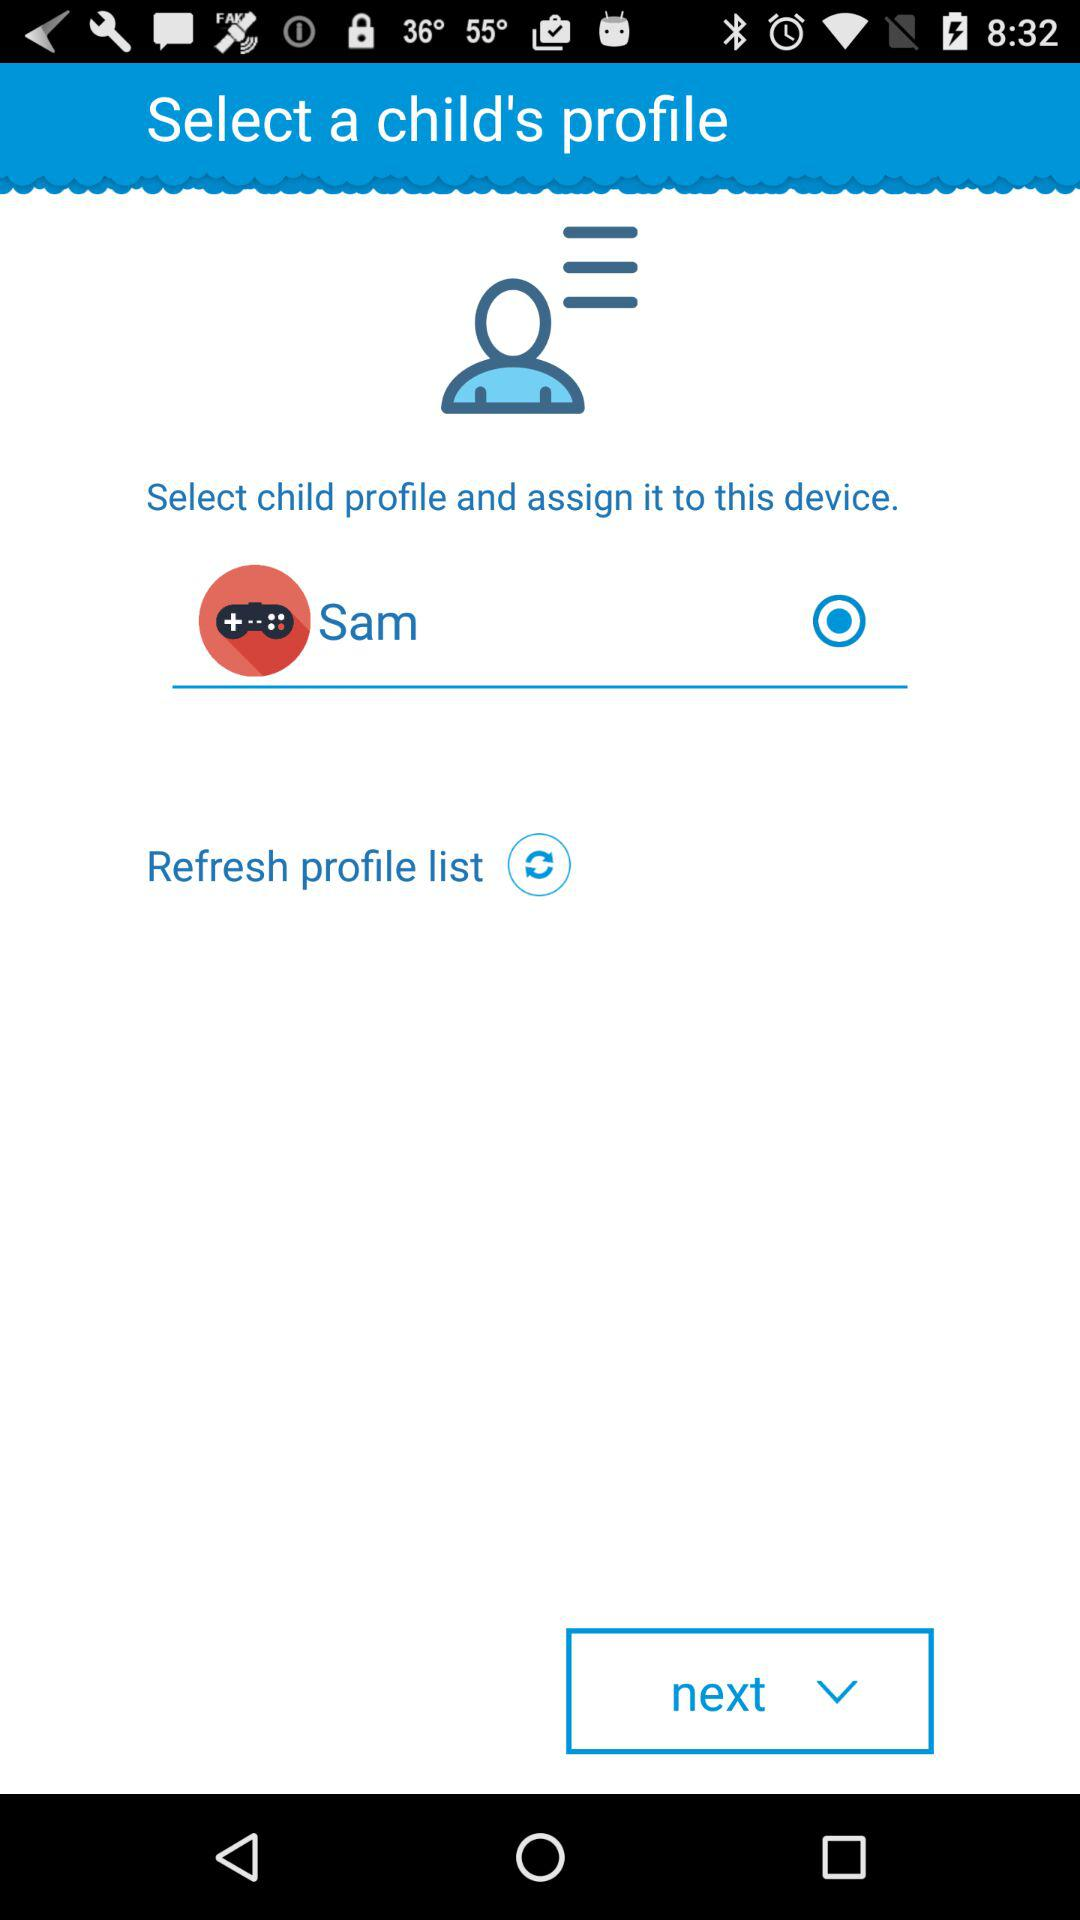Which gender is selected?
When the provided information is insufficient, respond with <no answer>. <no answer> 